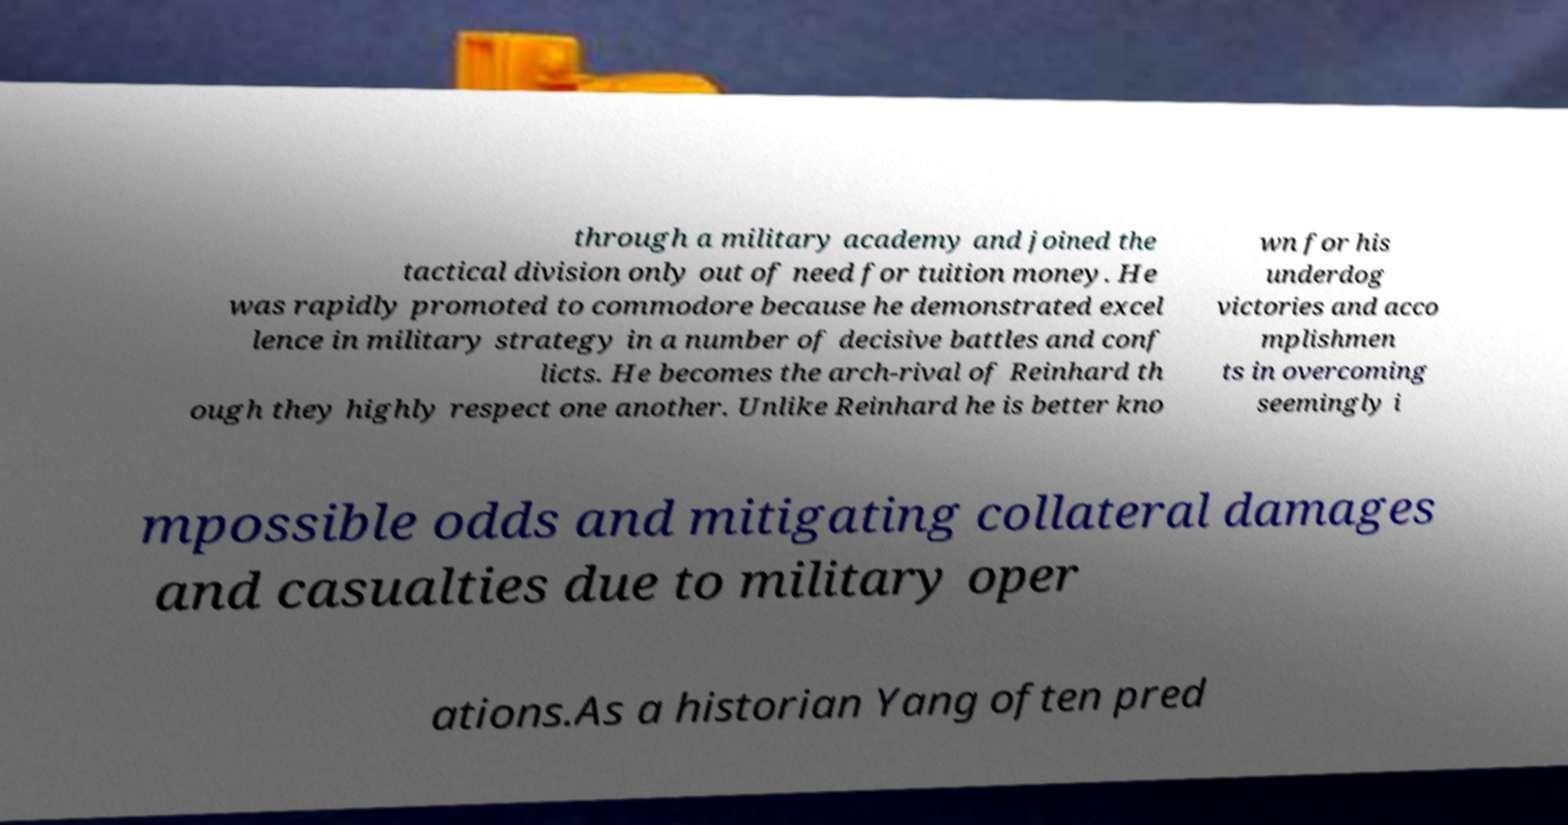Please read and relay the text visible in this image. What does it say? through a military academy and joined the tactical division only out of need for tuition money. He was rapidly promoted to commodore because he demonstrated excel lence in military strategy in a number of decisive battles and conf licts. He becomes the arch-rival of Reinhard th ough they highly respect one another. Unlike Reinhard he is better kno wn for his underdog victories and acco mplishmen ts in overcoming seemingly i mpossible odds and mitigating collateral damages and casualties due to military oper ations.As a historian Yang often pred 